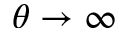Convert formula to latex. <formula><loc_0><loc_0><loc_500><loc_500>{ \theta \rightarrow \infty }</formula> 